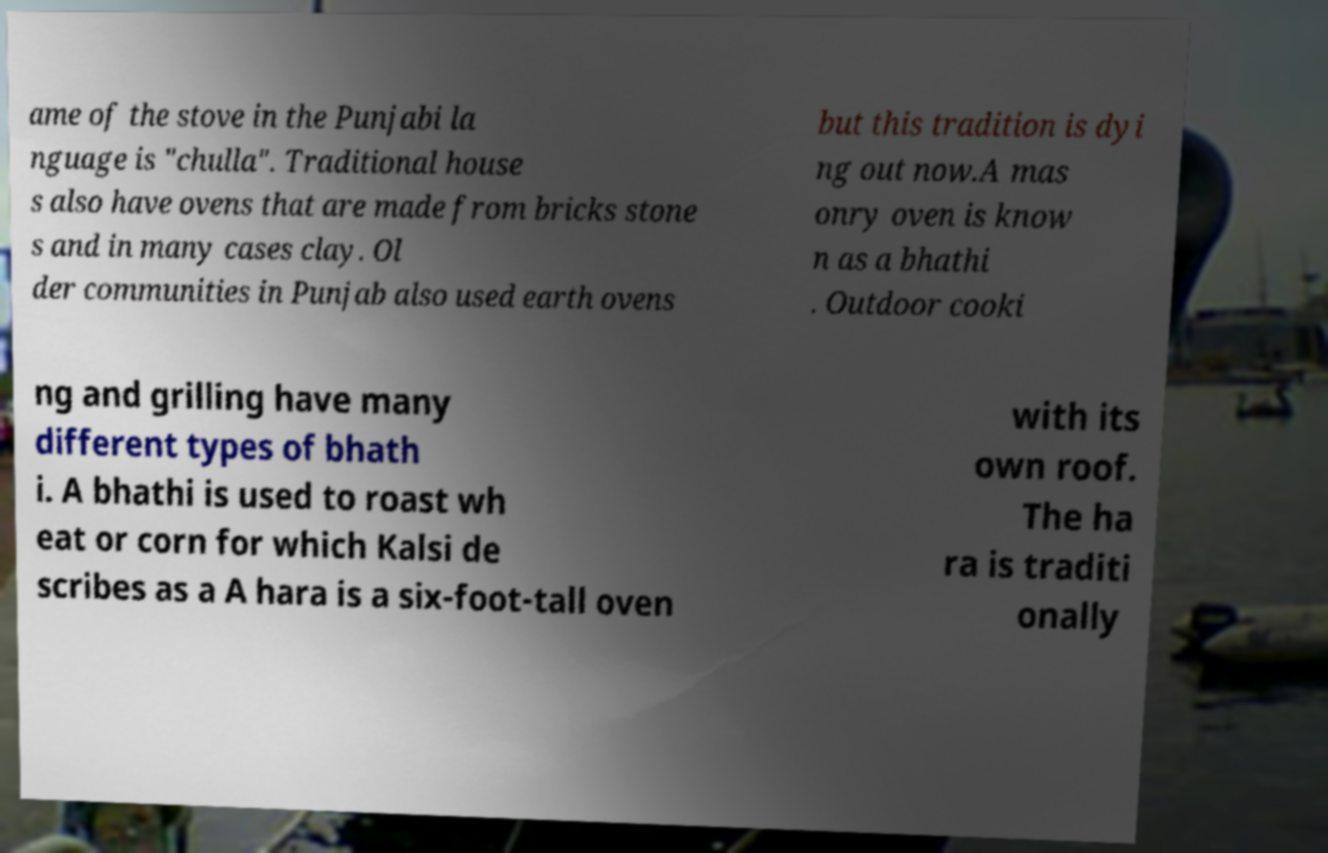Please identify and transcribe the text found in this image. ame of the stove in the Punjabi la nguage is "chulla". Traditional house s also have ovens that are made from bricks stone s and in many cases clay. Ol der communities in Punjab also used earth ovens but this tradition is dyi ng out now.A mas onry oven is know n as a bhathi . Outdoor cooki ng and grilling have many different types of bhath i. A bhathi is used to roast wh eat or corn for which Kalsi de scribes as a A hara is a six-foot-tall oven with its own roof. The ha ra is traditi onally 